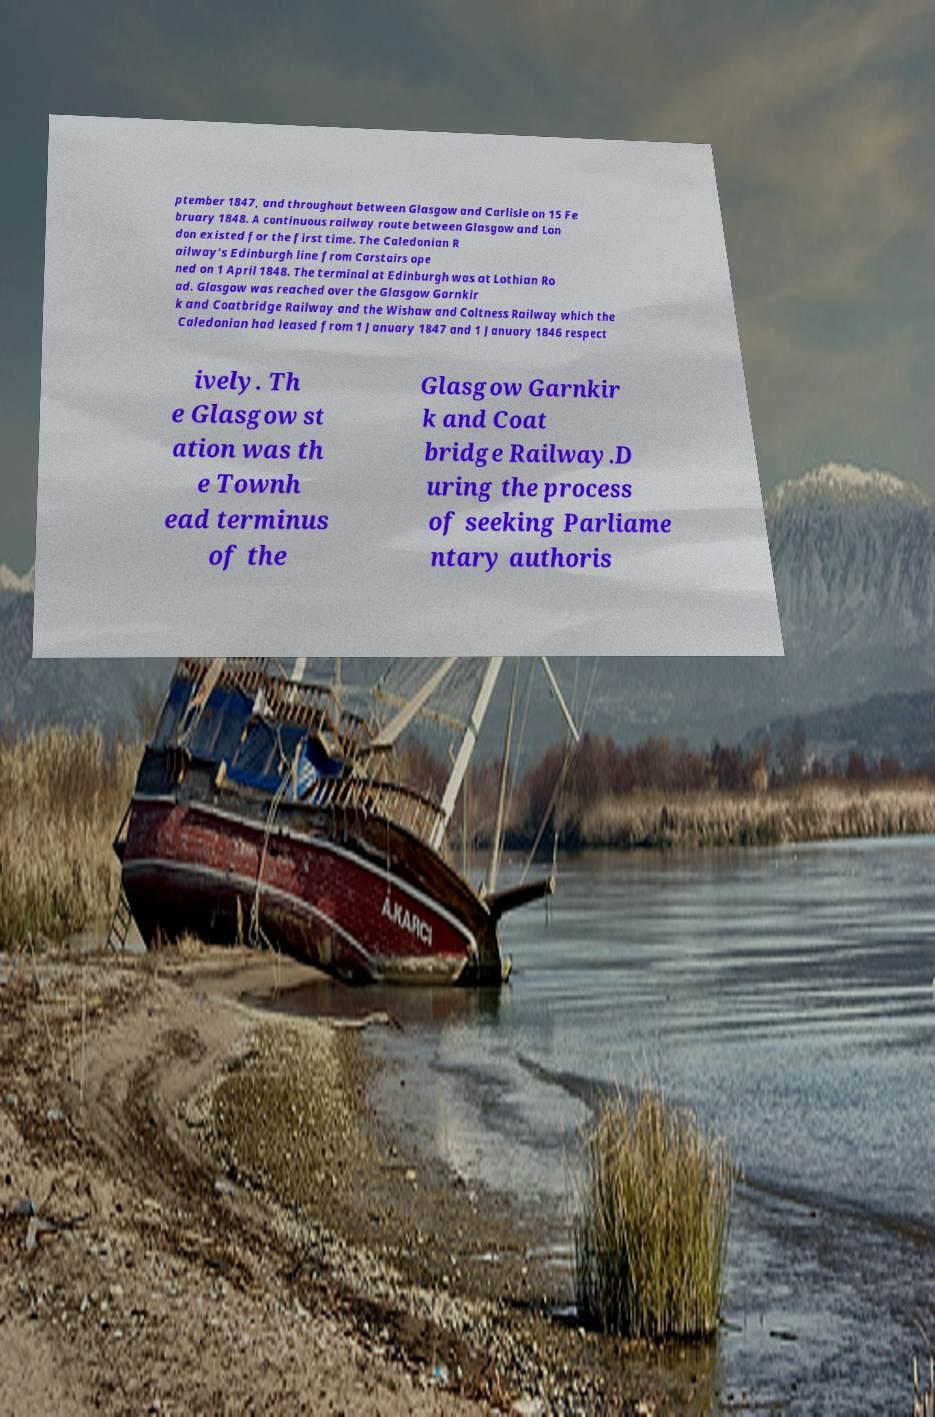I need the written content from this picture converted into text. Can you do that? ptember 1847, and throughout between Glasgow and Carlisle on 15 Fe bruary 1848. A continuous railway route between Glasgow and Lon don existed for the first time. The Caledonian R ailway's Edinburgh line from Carstairs ope ned on 1 April 1848. The terminal at Edinburgh was at Lothian Ro ad. Glasgow was reached over the Glasgow Garnkir k and Coatbridge Railway and the Wishaw and Coltness Railway which the Caledonian had leased from 1 January 1847 and 1 January 1846 respect ively. Th e Glasgow st ation was th e Townh ead terminus of the Glasgow Garnkir k and Coat bridge Railway.D uring the process of seeking Parliame ntary authoris 